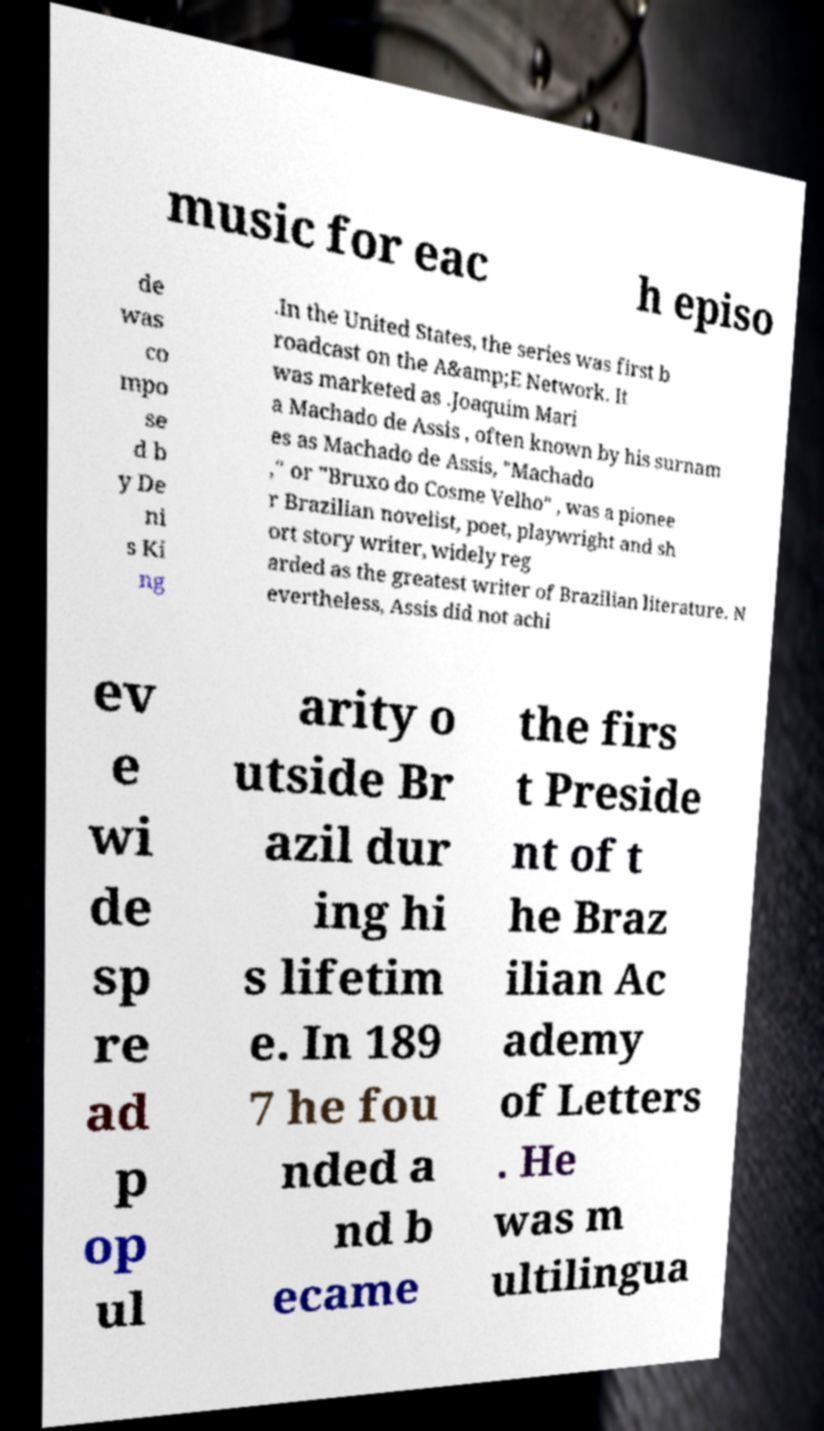Can you read and provide the text displayed in the image?This photo seems to have some interesting text. Can you extract and type it out for me? music for eac h episo de was co mpo se d b y De ni s Ki ng .In the United States, the series was first b roadcast on the A&amp;E Network. It was marketed as .Joaquim Mari a Machado de Assis , often known by his surnam es as Machado de Assis, "Machado ," or "Bruxo do Cosme Velho" , was a pionee r Brazilian novelist, poet, playwright and sh ort story writer, widely reg arded as the greatest writer of Brazilian literature. N evertheless, Assis did not achi ev e wi de sp re ad p op ul arity o utside Br azil dur ing hi s lifetim e. In 189 7 he fou nded a nd b ecame the firs t Preside nt of t he Braz ilian Ac ademy of Letters . He was m ultilingua 